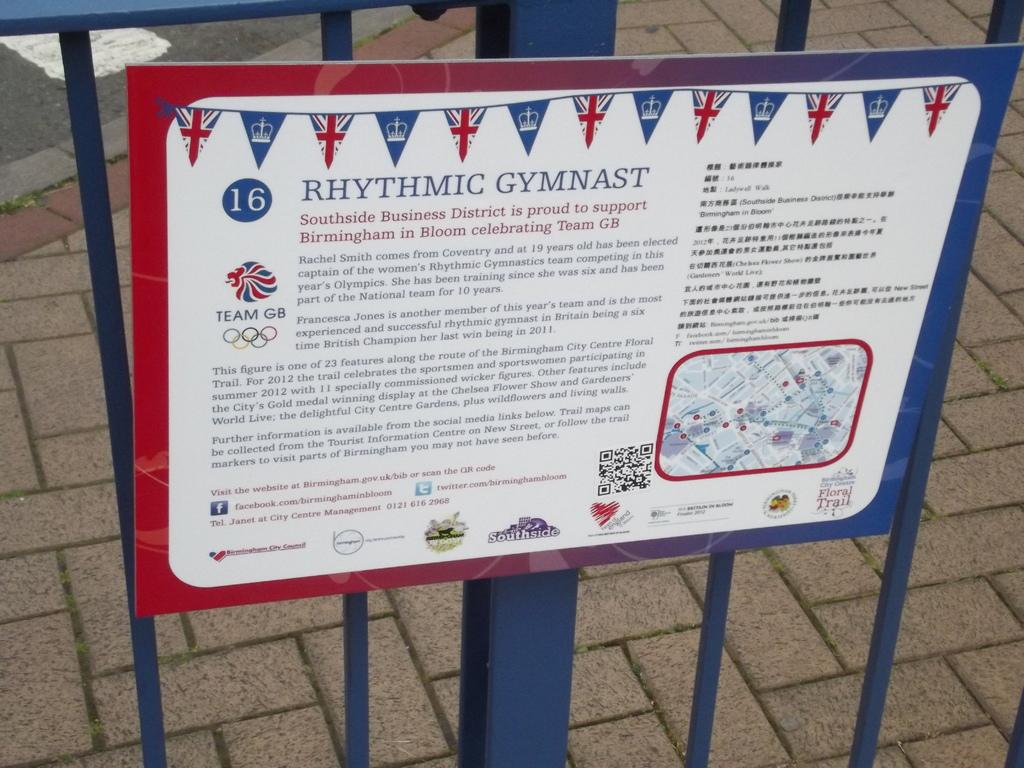<image>
Provide a brief description of the given image. A sign posted on the blue metal fence informs people about Rhythmic Gymnast. 